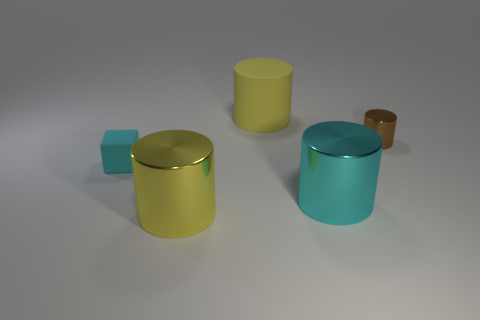The other object that is made of the same material as the small cyan thing is what color?
Your answer should be compact. Yellow. How many big yellow objects are the same material as the big cyan cylinder?
Your answer should be compact. 1. Do the brown thing and the yellow thing behind the small matte object have the same material?
Offer a terse response. No. What number of things are either large yellow objects that are in front of the cyan matte thing or big cyan shiny cylinders?
Ensure brevity in your answer.  2. What size is the yellow object in front of the matte object that is left of the large rubber thing behind the tiny brown metallic object?
Give a very brief answer. Large. What material is the large thing that is the same color as the small cube?
Ensure brevity in your answer.  Metal. Are there any other things that are the same shape as the brown thing?
Provide a short and direct response. Yes. There is a metal cylinder behind the big cyan metallic thing in front of the small metallic thing; how big is it?
Provide a short and direct response. Small. How many tiny things are purple metallic blocks or brown metallic things?
Your answer should be compact. 1. Are there fewer cyan cylinders than big things?
Make the answer very short. Yes. 